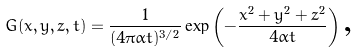Convert formula to latex. <formula><loc_0><loc_0><loc_500><loc_500>G ( x , y , z , t ) = \frac { 1 } { ( 4 \pi \alpha t ) ^ { 3 / 2 } } \exp \left ( - \frac { x ^ { 2 } + y ^ { 2 } + z ^ { 2 } } { 4 \alpha t } \right ) \text {,}</formula> 